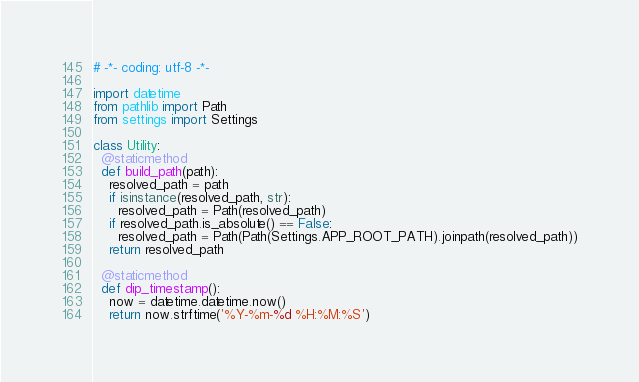<code> <loc_0><loc_0><loc_500><loc_500><_Python_># -*- coding: utf-8 -*-

import datetime
from pathlib import Path
from settings import Settings

class Utility:
  @staticmethod
  def build_path(path):
    resolved_path = path
    if isinstance(resolved_path, str):
      resolved_path = Path(resolved_path)
    if resolved_path.is_absolute() == False:
      resolved_path = Path(Path(Settings.APP_ROOT_PATH).joinpath(resolved_path))
    return resolved_path

  @staticmethod
  def dip_timestamp():
    now = datetime.datetime.now()
    return now.strftime('%Y-%m-%d %H:%M:%S')
</code> 